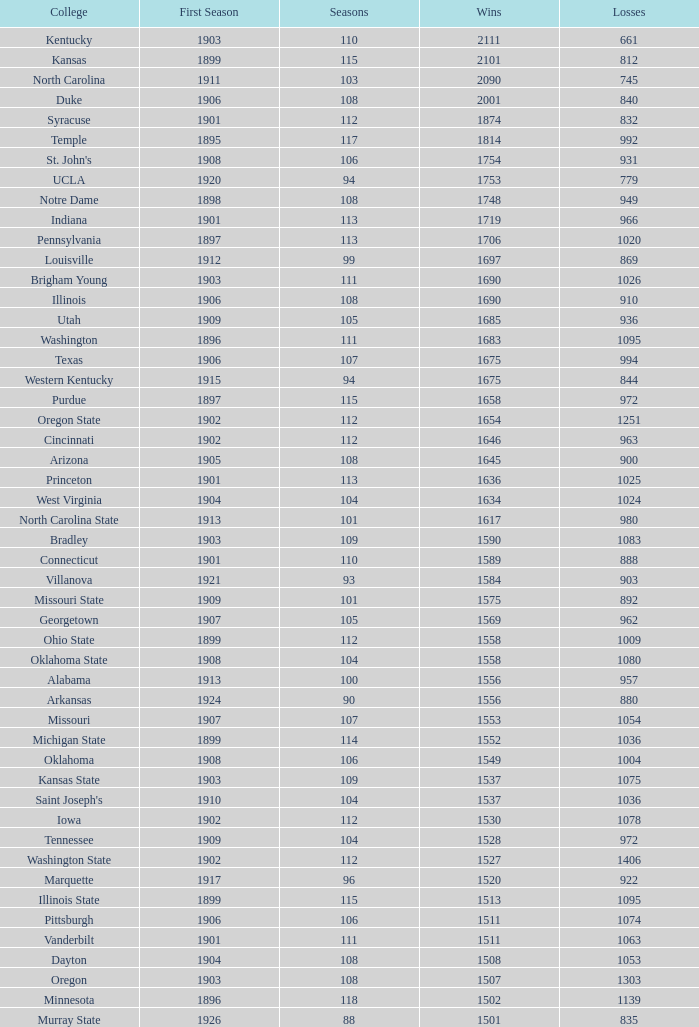How many victories did washington state college achieve with over 980 defeats, an initial season prior to 1906, and a ranking above 42? 0.0. Could you parse the entire table? {'header': ['College', 'First Season', 'Seasons', 'Wins', 'Losses'], 'rows': [['Kentucky', '1903', '110', '2111', '661'], ['Kansas', '1899', '115', '2101', '812'], ['North Carolina', '1911', '103', '2090', '745'], ['Duke', '1906', '108', '2001', '840'], ['Syracuse', '1901', '112', '1874', '832'], ['Temple', '1895', '117', '1814', '992'], ["St. John's", '1908', '106', '1754', '931'], ['UCLA', '1920', '94', '1753', '779'], ['Notre Dame', '1898', '108', '1748', '949'], ['Indiana', '1901', '113', '1719', '966'], ['Pennsylvania', '1897', '113', '1706', '1020'], ['Louisville', '1912', '99', '1697', '869'], ['Brigham Young', '1903', '111', '1690', '1026'], ['Illinois', '1906', '108', '1690', '910'], ['Utah', '1909', '105', '1685', '936'], ['Washington', '1896', '111', '1683', '1095'], ['Texas', '1906', '107', '1675', '994'], ['Western Kentucky', '1915', '94', '1675', '844'], ['Purdue', '1897', '115', '1658', '972'], ['Oregon State', '1902', '112', '1654', '1251'], ['Cincinnati', '1902', '112', '1646', '963'], ['Arizona', '1905', '108', '1645', '900'], ['Princeton', '1901', '113', '1636', '1025'], ['West Virginia', '1904', '104', '1634', '1024'], ['North Carolina State', '1913', '101', '1617', '980'], ['Bradley', '1903', '109', '1590', '1083'], ['Connecticut', '1901', '110', '1589', '888'], ['Villanova', '1921', '93', '1584', '903'], ['Missouri State', '1909', '101', '1575', '892'], ['Georgetown', '1907', '105', '1569', '962'], ['Ohio State', '1899', '112', '1558', '1009'], ['Oklahoma State', '1908', '104', '1558', '1080'], ['Alabama', '1913', '100', '1556', '957'], ['Arkansas', '1924', '90', '1556', '880'], ['Missouri', '1907', '107', '1553', '1054'], ['Michigan State', '1899', '114', '1552', '1036'], ['Oklahoma', '1908', '106', '1549', '1004'], ['Kansas State', '1903', '109', '1537', '1075'], ["Saint Joseph's", '1910', '104', '1537', '1036'], ['Iowa', '1902', '112', '1530', '1078'], ['Tennessee', '1909', '104', '1528', '972'], ['Washington State', '1902', '112', '1527', '1406'], ['Marquette', '1917', '96', '1520', '922'], ['Illinois State', '1899', '115', '1513', '1095'], ['Pittsburgh', '1906', '106', '1511', '1074'], ['Vanderbilt', '1901', '111', '1511', '1063'], ['Dayton', '1904', '108', '1508', '1053'], ['Oregon', '1903', '108', '1507', '1303'], ['Minnesota', '1896', '118', '1502', '1139'], ['Murray State', '1926', '88', '1501', '835']]} 